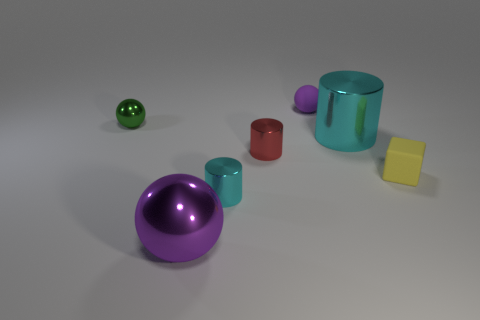What can you infer about the scale or size of this setup? Without a clear reference object, it's difficult to ascertain the exact scale, but the objects could be interpreted as tabletop items, potentially used for teaching purposes, such as a set of geometric shapes for educational demonstrations in math or physics. What might these objects be used to teach? These objects appear ideal for teaching concepts of geometry, volume, and surface area. Their distinct shapes – including spheres, cylinders, and cubes – can help illustrate the properties of different 3D figures in a visual and tangible way. 